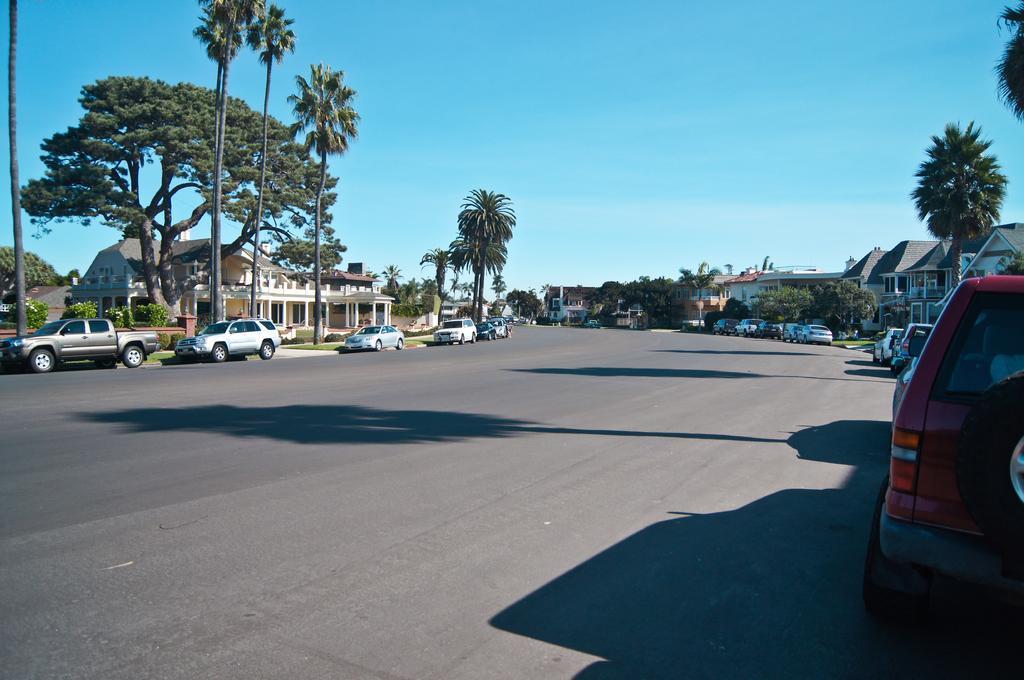Describe this image in one or two sentences. In this image there are trees. There are buildings. There are vehicles parked on the road. At the top of the image there is sky. 